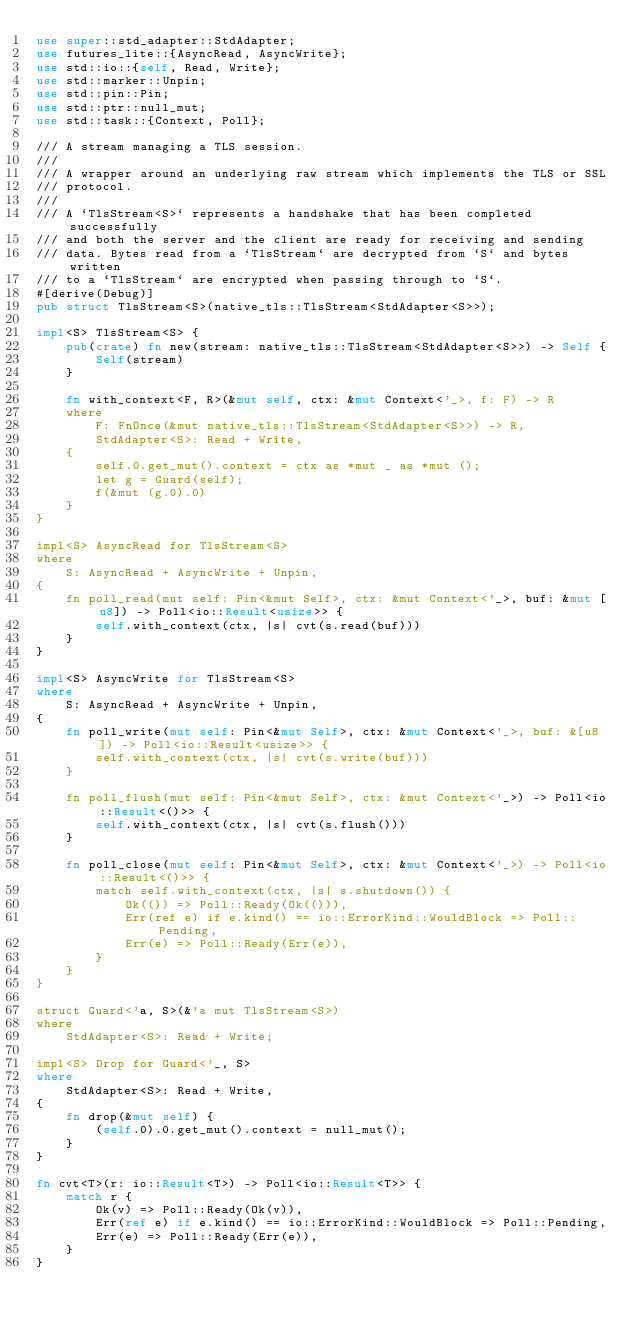<code> <loc_0><loc_0><loc_500><loc_500><_Rust_>use super::std_adapter::StdAdapter;
use futures_lite::{AsyncRead, AsyncWrite};
use std::io::{self, Read, Write};
use std::marker::Unpin;
use std::pin::Pin;
use std::ptr::null_mut;
use std::task::{Context, Poll};

/// A stream managing a TLS session.
///
/// A wrapper around an underlying raw stream which implements the TLS or SSL
/// protocol.
///
/// A `TlsStream<S>` represents a handshake that has been completed successfully
/// and both the server and the client are ready for receiving and sending
/// data. Bytes read from a `TlsStream` are decrypted from `S` and bytes written
/// to a `TlsStream` are encrypted when passing through to `S`.
#[derive(Debug)]
pub struct TlsStream<S>(native_tls::TlsStream<StdAdapter<S>>);

impl<S> TlsStream<S> {
    pub(crate) fn new(stream: native_tls::TlsStream<StdAdapter<S>>) -> Self {
        Self(stream)
    }

    fn with_context<F, R>(&mut self, ctx: &mut Context<'_>, f: F) -> R
    where
        F: FnOnce(&mut native_tls::TlsStream<StdAdapter<S>>) -> R,
        StdAdapter<S>: Read + Write,
    {
        self.0.get_mut().context = ctx as *mut _ as *mut ();
        let g = Guard(self);
        f(&mut (g.0).0)
    }
}

impl<S> AsyncRead for TlsStream<S>
where
    S: AsyncRead + AsyncWrite + Unpin,
{
    fn poll_read(mut self: Pin<&mut Self>, ctx: &mut Context<'_>, buf: &mut [u8]) -> Poll<io::Result<usize>> {
        self.with_context(ctx, |s| cvt(s.read(buf)))
    }
}

impl<S> AsyncWrite for TlsStream<S>
where
    S: AsyncRead + AsyncWrite + Unpin,
{
    fn poll_write(mut self: Pin<&mut Self>, ctx: &mut Context<'_>, buf: &[u8]) -> Poll<io::Result<usize>> {
        self.with_context(ctx, |s| cvt(s.write(buf)))
    }

    fn poll_flush(mut self: Pin<&mut Self>, ctx: &mut Context<'_>) -> Poll<io::Result<()>> {
        self.with_context(ctx, |s| cvt(s.flush()))
    }

    fn poll_close(mut self: Pin<&mut Self>, ctx: &mut Context<'_>) -> Poll<io::Result<()>> {
        match self.with_context(ctx, |s| s.shutdown()) {
            Ok(()) => Poll::Ready(Ok(())),
            Err(ref e) if e.kind() == io::ErrorKind::WouldBlock => Poll::Pending,
            Err(e) => Poll::Ready(Err(e)),
        }
    }
}

struct Guard<'a, S>(&'a mut TlsStream<S>)
where
    StdAdapter<S>: Read + Write;

impl<S> Drop for Guard<'_, S>
where
    StdAdapter<S>: Read + Write,
{
    fn drop(&mut self) {
        (self.0).0.get_mut().context = null_mut();
    }
}

fn cvt<T>(r: io::Result<T>) -> Poll<io::Result<T>> {
    match r {
        Ok(v) => Poll::Ready(Ok(v)),
        Err(ref e) if e.kind() == io::ErrorKind::WouldBlock => Poll::Pending,
        Err(e) => Poll::Ready(Err(e)),
    }
}
</code> 